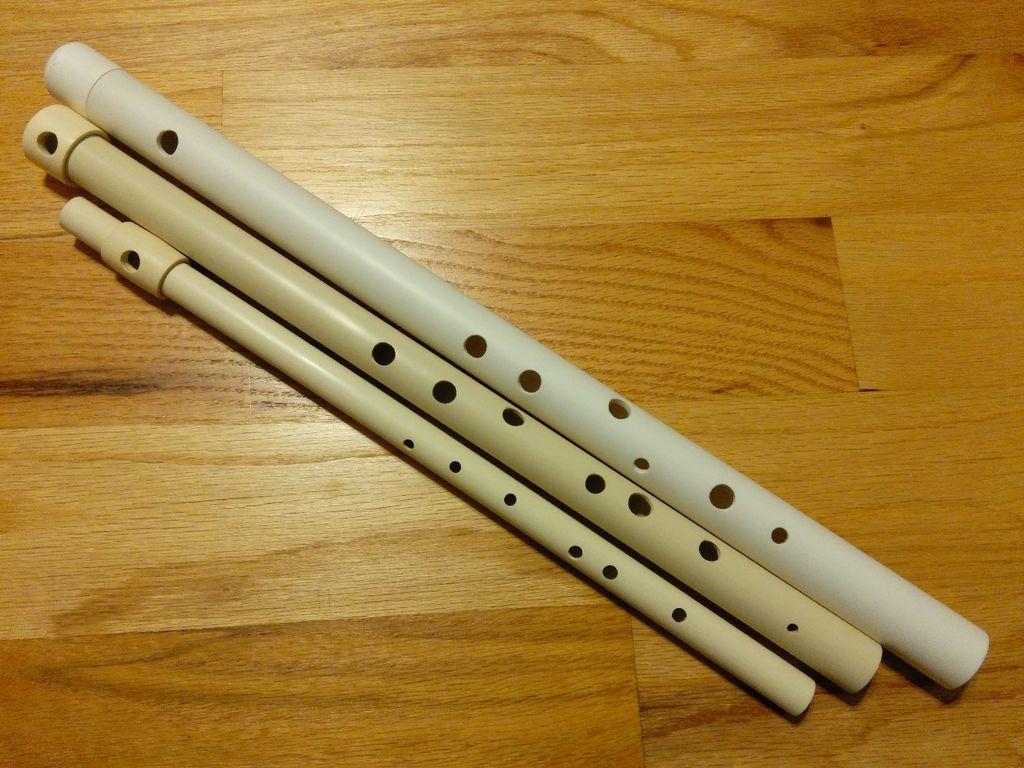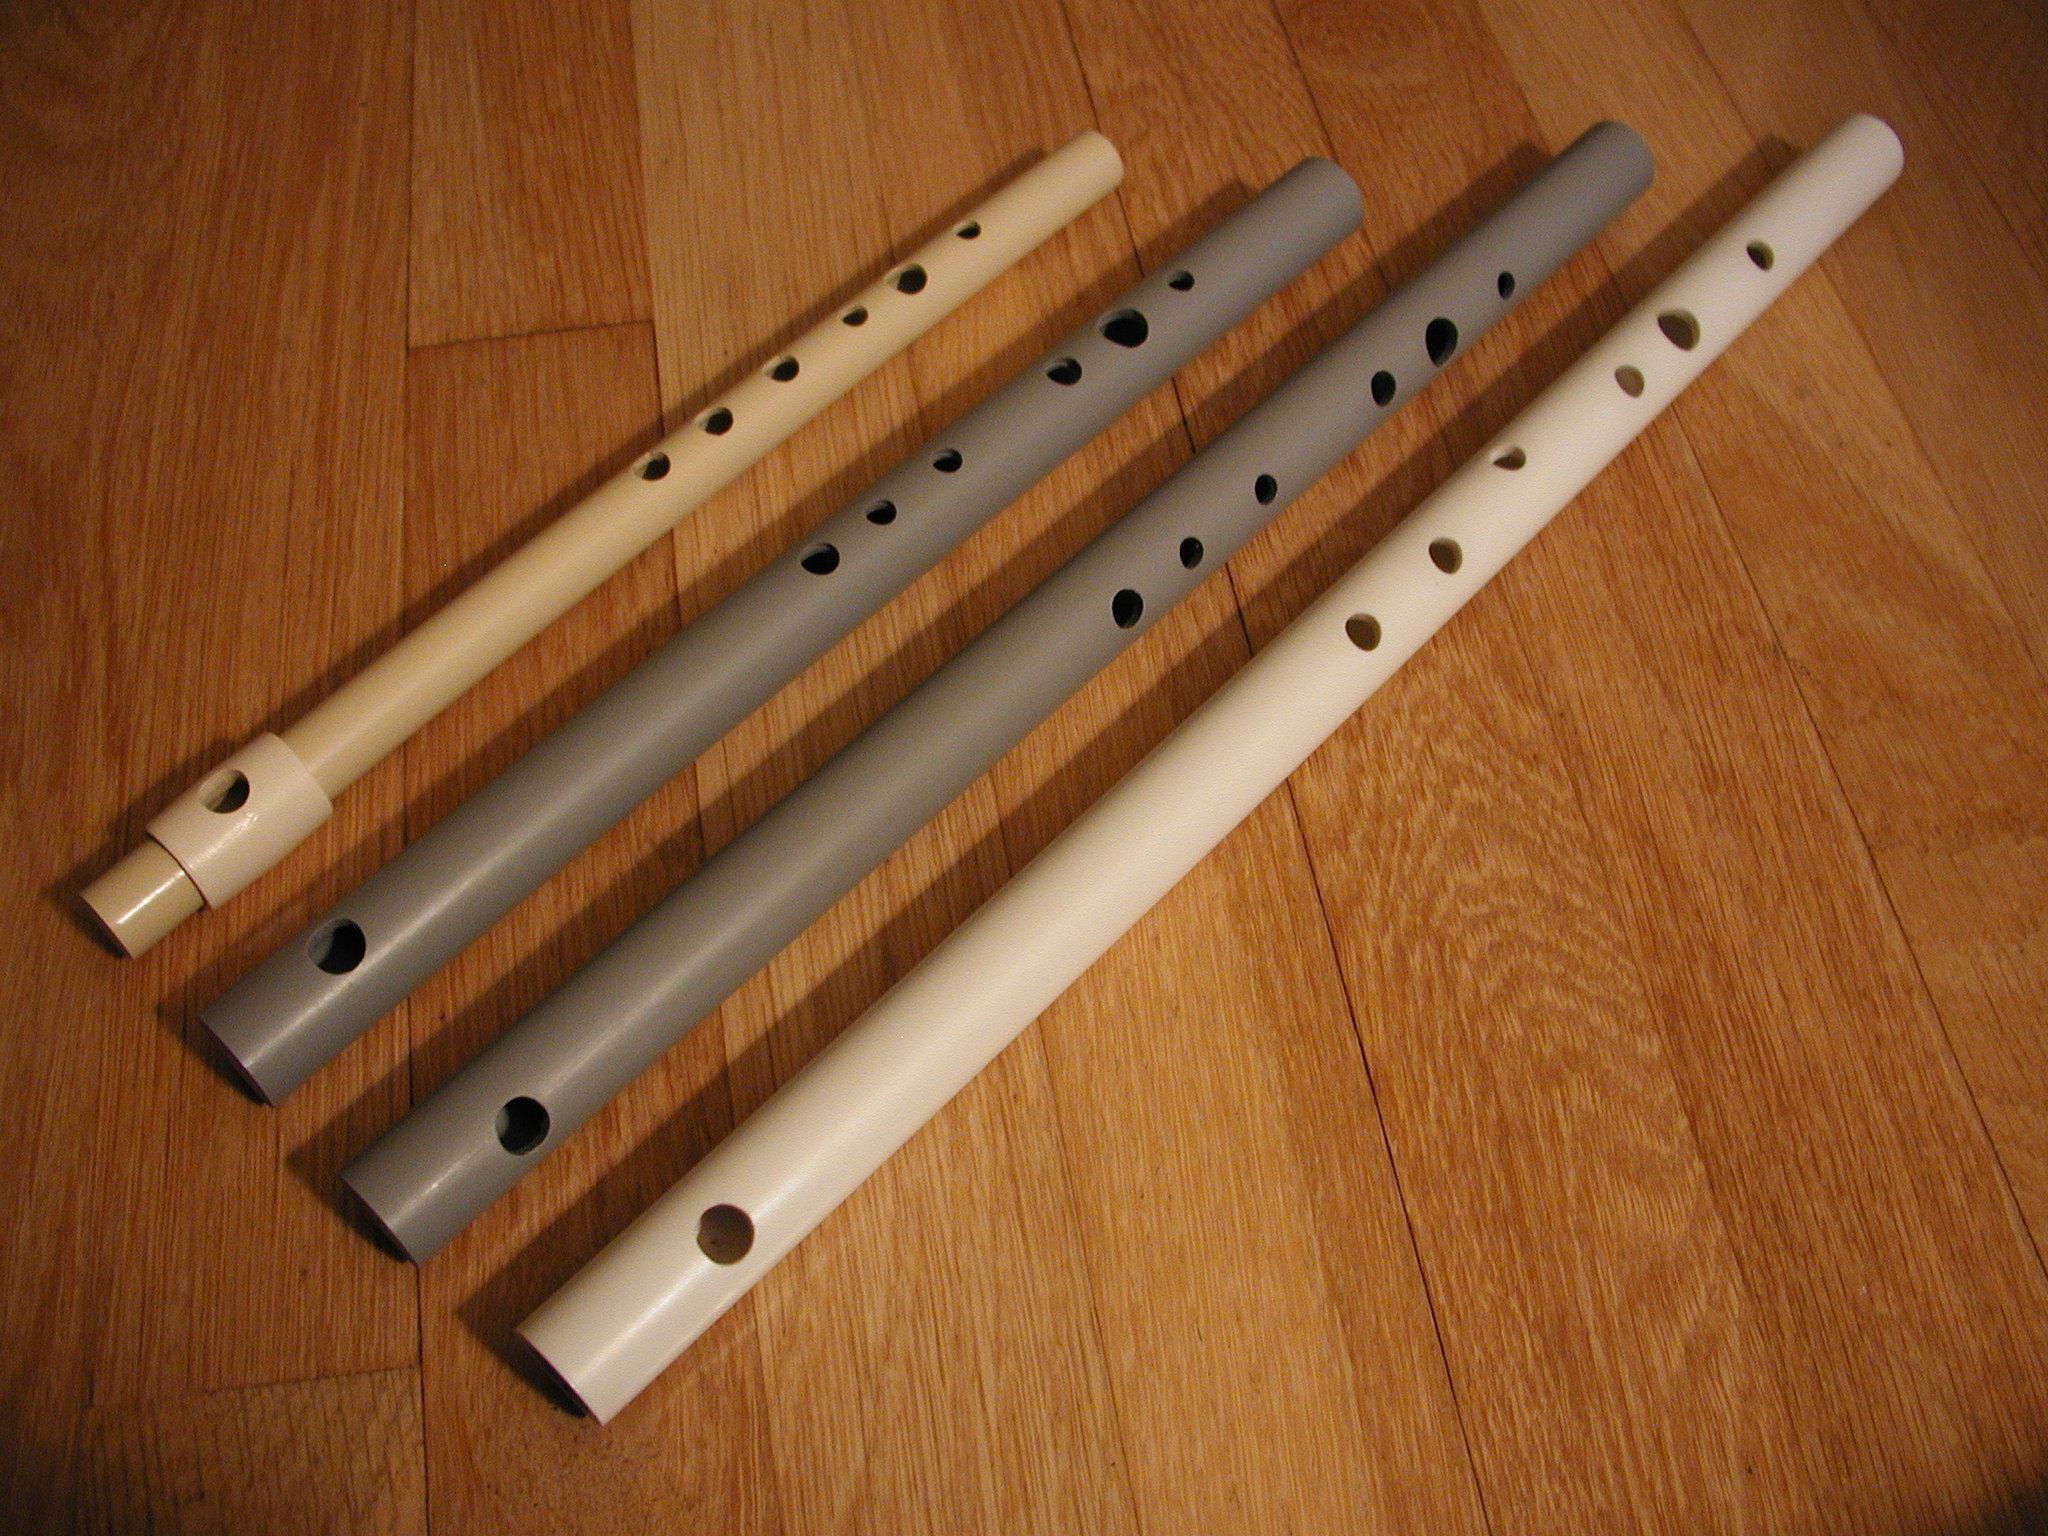The first image is the image on the left, the second image is the image on the right. For the images displayed, is the sentence "The combined images contain exactly five flute-related objects." factually correct? Answer yes or no. No. The first image is the image on the left, the second image is the image on the right. Considering the images on both sides, is "There is exactly one flute in the right image." valid? Answer yes or no. No. 